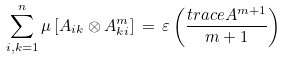Convert formula to latex. <formula><loc_0><loc_0><loc_500><loc_500>\sum _ { i , k = 1 } ^ { n } \mu \, [ A _ { i k } \otimes A ^ { m } _ { k i } ] \, = \, \varepsilon \left ( \frac { t r a c e A ^ { m + 1 } } { m + 1 } \right )</formula> 